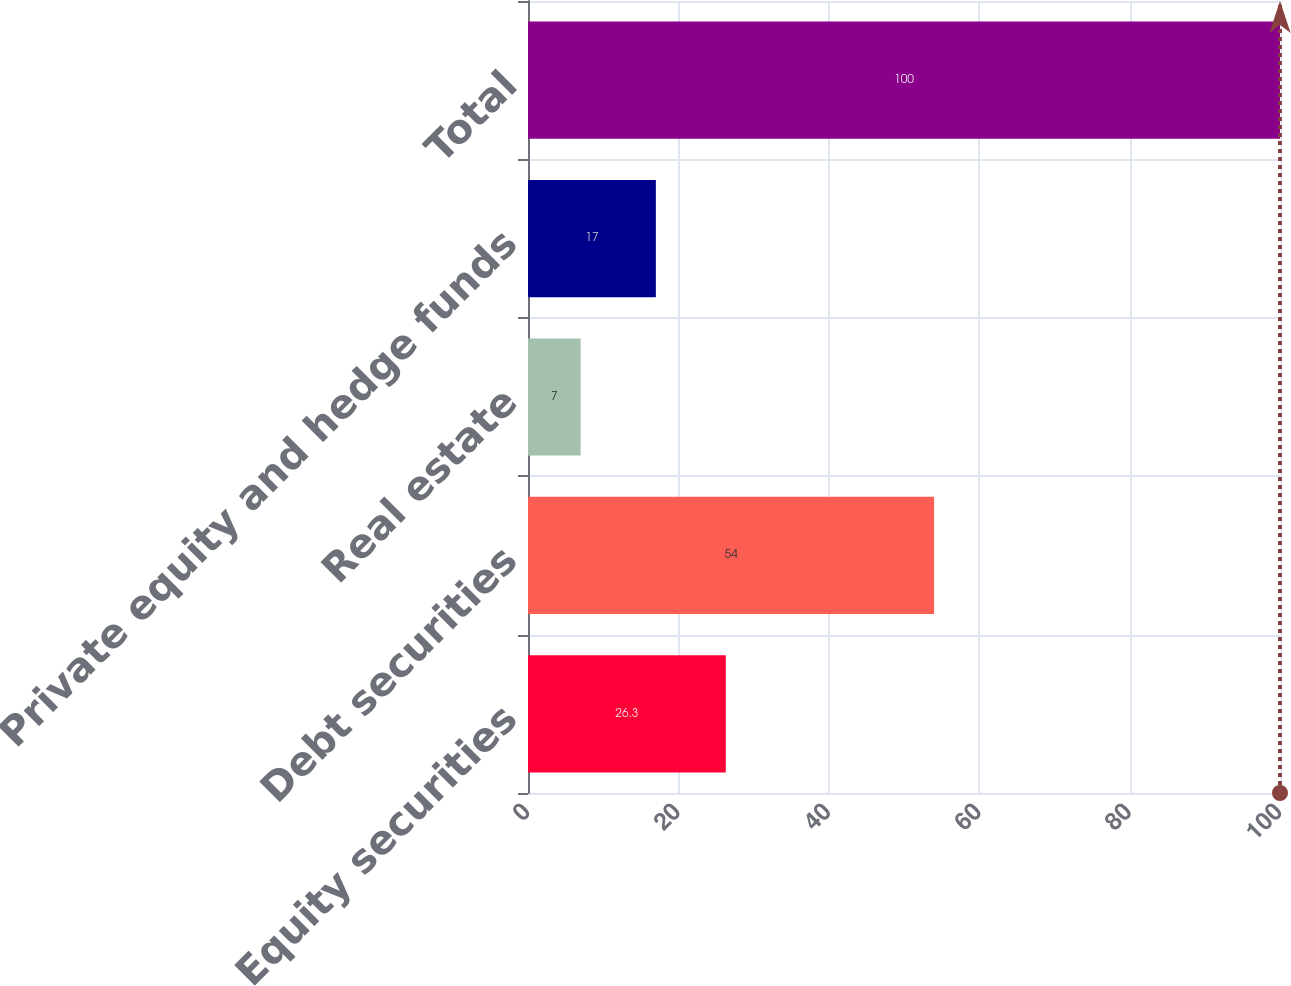Convert chart to OTSL. <chart><loc_0><loc_0><loc_500><loc_500><bar_chart><fcel>Equity securities<fcel>Debt securities<fcel>Real estate<fcel>Private equity and hedge funds<fcel>Total<nl><fcel>26.3<fcel>54<fcel>7<fcel>17<fcel>100<nl></chart> 